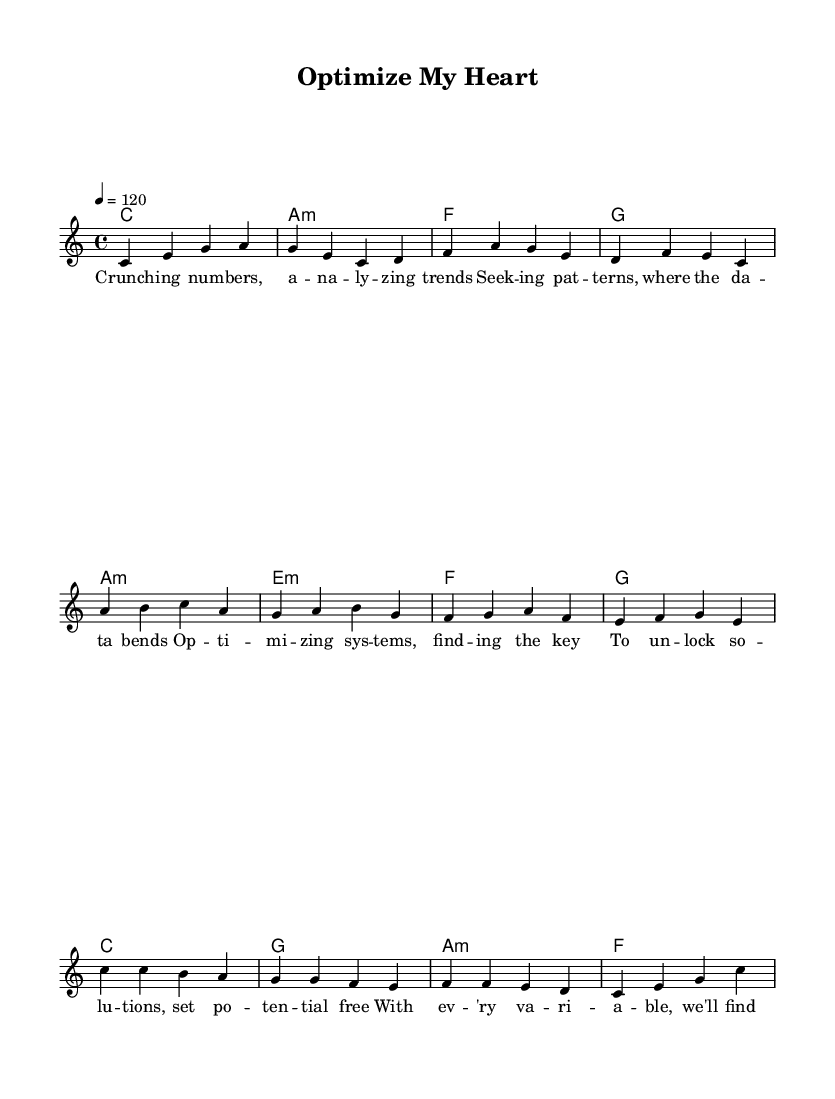What is the key signature of this music? The key signature is indicated at the beginning of the score, showing no sharps or flats, which is characteristic of C major.
Answer: C major What is the time signature of this music? The time signature is found at the beginning, and it is represented by the 4/4 notation, meaning there are four beats per measure.
Answer: 4/4 What is the tempo marking for this song? The tempo marking indicates a speed of 120 beats per minute, which is shown in the tempo line at the beginning of the score.
Answer: 120 How many measures are in the verse? The verse section consists of four measures, identifiable by the four lines of music before the pre-chorus begins.
Answer: 4 Which chords are used in the chorus? By examining the chord progression listed with the melody, the chorus includes the chords C, G, A minor, and F.
Answer: C, G, A minor, F What lyrical themes can be identified in the lyrics? The lyrics focus on innovation and problem-solving in data analysis, emphasizing the importance of finding patterns and solutions.
Answer: Data analysis and innovation How are the melody and harmonies structured in the verse? The verse features a melody that aligns with the harmonic structure, with each measure corresponding to a specific chord, creating a cohesive musical flow.
Answer: Melody aligns with harmonies 